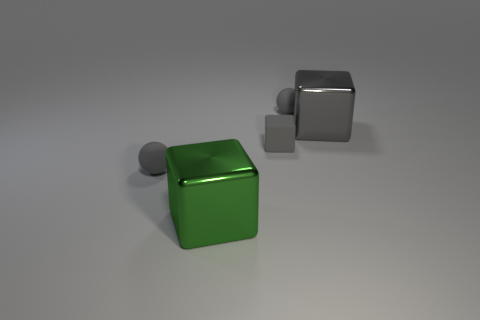Subtract all tiny matte blocks. How many blocks are left? 2 Add 3 small cyan shiny cylinders. How many objects exist? 8 Subtract all green blocks. How many blocks are left? 2 Subtract 1 balls. How many balls are left? 1 Subtract all red balls. Subtract all yellow blocks. How many balls are left? 2 Subtract all red balls. How many gray blocks are left? 2 Subtract all large blue objects. Subtract all large green metallic things. How many objects are left? 4 Add 2 big gray metal things. How many big gray metal things are left? 3 Add 2 big green metal blocks. How many big green metal blocks exist? 3 Subtract 0 purple spheres. How many objects are left? 5 